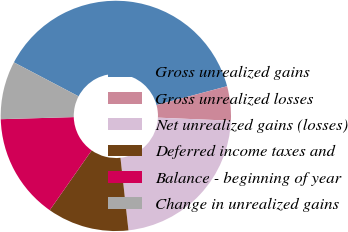Convert chart. <chart><loc_0><loc_0><loc_500><loc_500><pie_chart><fcel>Gross unrealized gains<fcel>Gross unrealized losses<fcel>Net unrealized gains (losses)<fcel>Deferred income taxes and<fcel>Balance - beginning of year<fcel>Change in unrealized gains<nl><fcel>38.15%<fcel>4.81%<fcel>22.59%<fcel>11.48%<fcel>14.81%<fcel>8.15%<nl></chart> 